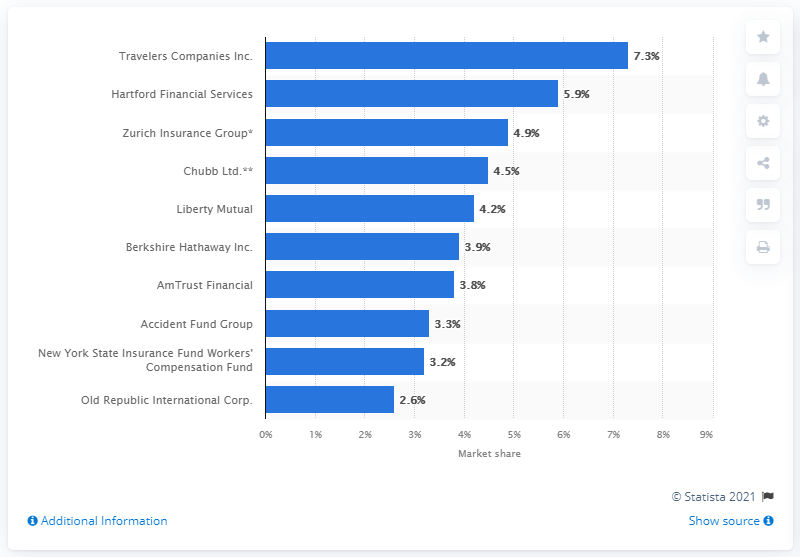Point out several critical features in this image. In 2020, the market share of Travelers Companies Inc. was 7.3%. 